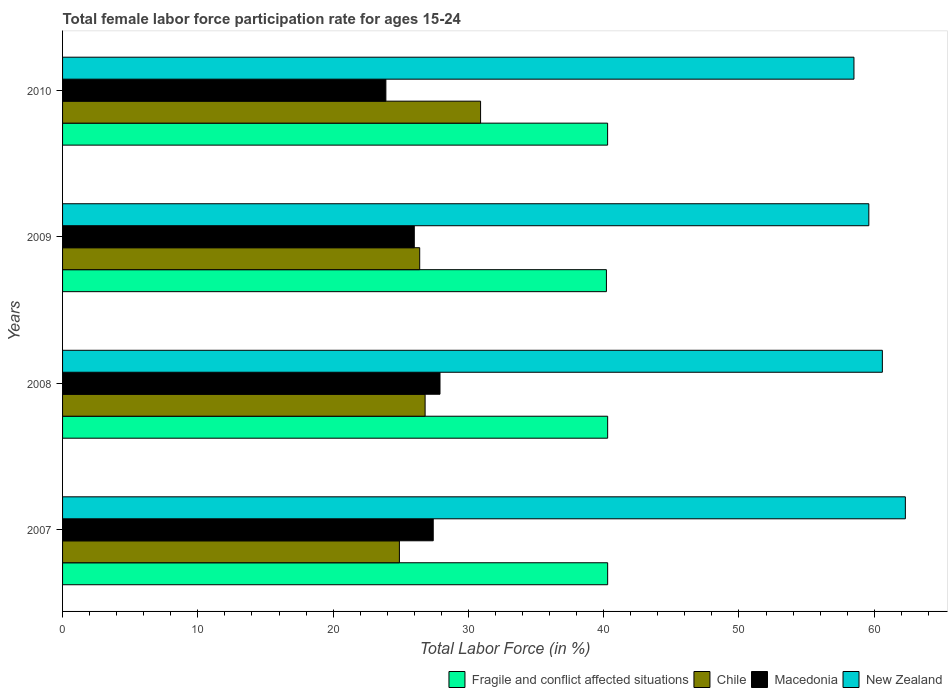Are the number of bars per tick equal to the number of legend labels?
Offer a terse response. Yes. Are the number of bars on each tick of the Y-axis equal?
Your answer should be compact. Yes. What is the female labor force participation rate in Chile in 2009?
Your answer should be very brief. 26.4. Across all years, what is the maximum female labor force participation rate in Fragile and conflict affected situations?
Give a very brief answer. 40.29. Across all years, what is the minimum female labor force participation rate in Macedonia?
Your answer should be very brief. 23.9. In which year was the female labor force participation rate in Fragile and conflict affected situations maximum?
Offer a very short reply. 2007. In which year was the female labor force participation rate in Chile minimum?
Provide a short and direct response. 2007. What is the total female labor force participation rate in Chile in the graph?
Offer a very short reply. 109. What is the difference between the female labor force participation rate in New Zealand in 2007 and that in 2008?
Ensure brevity in your answer.  1.7. What is the difference between the female labor force participation rate in Macedonia in 2009 and the female labor force participation rate in Fragile and conflict affected situations in 2008?
Keep it short and to the point. -14.29. What is the average female labor force participation rate in Chile per year?
Make the answer very short. 27.25. In the year 2009, what is the difference between the female labor force participation rate in Macedonia and female labor force participation rate in Fragile and conflict affected situations?
Offer a terse response. -14.2. In how many years, is the female labor force participation rate in New Zealand greater than 48 %?
Your answer should be compact. 4. What is the ratio of the female labor force participation rate in New Zealand in 2008 to that in 2010?
Keep it short and to the point. 1.04. Is the female labor force participation rate in New Zealand in 2008 less than that in 2009?
Give a very brief answer. No. Is the difference between the female labor force participation rate in Macedonia in 2007 and 2009 greater than the difference between the female labor force participation rate in Fragile and conflict affected situations in 2007 and 2009?
Ensure brevity in your answer.  Yes. What is the difference between the highest and the lowest female labor force participation rate in New Zealand?
Your response must be concise. 3.8. In how many years, is the female labor force participation rate in Fragile and conflict affected situations greater than the average female labor force participation rate in Fragile and conflict affected situations taken over all years?
Keep it short and to the point. 3. Is the sum of the female labor force participation rate in New Zealand in 2008 and 2009 greater than the maximum female labor force participation rate in Macedonia across all years?
Keep it short and to the point. Yes. Is it the case that in every year, the sum of the female labor force participation rate in New Zealand and female labor force participation rate in Macedonia is greater than the sum of female labor force participation rate in Chile and female labor force participation rate in Fragile and conflict affected situations?
Provide a short and direct response. Yes. What does the 4th bar from the bottom in 2009 represents?
Your response must be concise. New Zealand. How many bars are there?
Offer a terse response. 16. Are all the bars in the graph horizontal?
Ensure brevity in your answer.  Yes. Does the graph contain grids?
Ensure brevity in your answer.  No. Where does the legend appear in the graph?
Your response must be concise. Bottom right. How are the legend labels stacked?
Provide a succinct answer. Horizontal. What is the title of the graph?
Offer a very short reply. Total female labor force participation rate for ages 15-24. What is the label or title of the X-axis?
Keep it short and to the point. Total Labor Force (in %). What is the Total Labor Force (in %) in Fragile and conflict affected situations in 2007?
Your response must be concise. 40.29. What is the Total Labor Force (in %) in Chile in 2007?
Your answer should be compact. 24.9. What is the Total Labor Force (in %) in Macedonia in 2007?
Your answer should be very brief. 27.4. What is the Total Labor Force (in %) of New Zealand in 2007?
Offer a terse response. 62.3. What is the Total Labor Force (in %) of Fragile and conflict affected situations in 2008?
Offer a very short reply. 40.29. What is the Total Labor Force (in %) of Chile in 2008?
Ensure brevity in your answer.  26.8. What is the Total Labor Force (in %) in Macedonia in 2008?
Keep it short and to the point. 27.9. What is the Total Labor Force (in %) of New Zealand in 2008?
Keep it short and to the point. 60.6. What is the Total Labor Force (in %) in Fragile and conflict affected situations in 2009?
Ensure brevity in your answer.  40.2. What is the Total Labor Force (in %) of Chile in 2009?
Make the answer very short. 26.4. What is the Total Labor Force (in %) in Macedonia in 2009?
Offer a very short reply. 26. What is the Total Labor Force (in %) in New Zealand in 2009?
Provide a short and direct response. 59.6. What is the Total Labor Force (in %) in Fragile and conflict affected situations in 2010?
Make the answer very short. 40.29. What is the Total Labor Force (in %) in Chile in 2010?
Keep it short and to the point. 30.9. What is the Total Labor Force (in %) in Macedonia in 2010?
Make the answer very short. 23.9. What is the Total Labor Force (in %) of New Zealand in 2010?
Give a very brief answer. 58.5. Across all years, what is the maximum Total Labor Force (in %) in Fragile and conflict affected situations?
Ensure brevity in your answer.  40.29. Across all years, what is the maximum Total Labor Force (in %) of Chile?
Your answer should be very brief. 30.9. Across all years, what is the maximum Total Labor Force (in %) in Macedonia?
Provide a short and direct response. 27.9. Across all years, what is the maximum Total Labor Force (in %) of New Zealand?
Your answer should be compact. 62.3. Across all years, what is the minimum Total Labor Force (in %) in Fragile and conflict affected situations?
Ensure brevity in your answer.  40.2. Across all years, what is the minimum Total Labor Force (in %) of Chile?
Offer a terse response. 24.9. Across all years, what is the minimum Total Labor Force (in %) in Macedonia?
Your answer should be very brief. 23.9. Across all years, what is the minimum Total Labor Force (in %) in New Zealand?
Provide a succinct answer. 58.5. What is the total Total Labor Force (in %) of Fragile and conflict affected situations in the graph?
Ensure brevity in your answer.  161.08. What is the total Total Labor Force (in %) of Chile in the graph?
Keep it short and to the point. 109. What is the total Total Labor Force (in %) in Macedonia in the graph?
Offer a terse response. 105.2. What is the total Total Labor Force (in %) of New Zealand in the graph?
Offer a very short reply. 241. What is the difference between the Total Labor Force (in %) in Fragile and conflict affected situations in 2007 and that in 2009?
Ensure brevity in your answer.  0.09. What is the difference between the Total Labor Force (in %) in Macedonia in 2007 and that in 2009?
Offer a very short reply. 1.4. What is the difference between the Total Labor Force (in %) of New Zealand in 2007 and that in 2009?
Keep it short and to the point. 2.7. What is the difference between the Total Labor Force (in %) in Fragile and conflict affected situations in 2007 and that in 2010?
Your response must be concise. 0. What is the difference between the Total Labor Force (in %) of Chile in 2007 and that in 2010?
Your answer should be very brief. -6. What is the difference between the Total Labor Force (in %) of New Zealand in 2007 and that in 2010?
Your answer should be very brief. 3.8. What is the difference between the Total Labor Force (in %) of Fragile and conflict affected situations in 2008 and that in 2009?
Give a very brief answer. 0.09. What is the difference between the Total Labor Force (in %) of Macedonia in 2008 and that in 2009?
Keep it short and to the point. 1.9. What is the difference between the Total Labor Force (in %) in New Zealand in 2008 and that in 2009?
Your answer should be very brief. 1. What is the difference between the Total Labor Force (in %) of Fragile and conflict affected situations in 2008 and that in 2010?
Provide a succinct answer. 0. What is the difference between the Total Labor Force (in %) of New Zealand in 2008 and that in 2010?
Give a very brief answer. 2.1. What is the difference between the Total Labor Force (in %) of Fragile and conflict affected situations in 2009 and that in 2010?
Ensure brevity in your answer.  -0.09. What is the difference between the Total Labor Force (in %) in Macedonia in 2009 and that in 2010?
Keep it short and to the point. 2.1. What is the difference between the Total Labor Force (in %) of Fragile and conflict affected situations in 2007 and the Total Labor Force (in %) of Chile in 2008?
Offer a terse response. 13.49. What is the difference between the Total Labor Force (in %) in Fragile and conflict affected situations in 2007 and the Total Labor Force (in %) in Macedonia in 2008?
Your answer should be compact. 12.39. What is the difference between the Total Labor Force (in %) of Fragile and conflict affected situations in 2007 and the Total Labor Force (in %) of New Zealand in 2008?
Keep it short and to the point. -20.31. What is the difference between the Total Labor Force (in %) of Chile in 2007 and the Total Labor Force (in %) of Macedonia in 2008?
Offer a terse response. -3. What is the difference between the Total Labor Force (in %) in Chile in 2007 and the Total Labor Force (in %) in New Zealand in 2008?
Your answer should be very brief. -35.7. What is the difference between the Total Labor Force (in %) of Macedonia in 2007 and the Total Labor Force (in %) of New Zealand in 2008?
Your response must be concise. -33.2. What is the difference between the Total Labor Force (in %) of Fragile and conflict affected situations in 2007 and the Total Labor Force (in %) of Chile in 2009?
Keep it short and to the point. 13.89. What is the difference between the Total Labor Force (in %) in Fragile and conflict affected situations in 2007 and the Total Labor Force (in %) in Macedonia in 2009?
Ensure brevity in your answer.  14.29. What is the difference between the Total Labor Force (in %) of Fragile and conflict affected situations in 2007 and the Total Labor Force (in %) of New Zealand in 2009?
Give a very brief answer. -19.31. What is the difference between the Total Labor Force (in %) in Chile in 2007 and the Total Labor Force (in %) in Macedonia in 2009?
Make the answer very short. -1.1. What is the difference between the Total Labor Force (in %) of Chile in 2007 and the Total Labor Force (in %) of New Zealand in 2009?
Give a very brief answer. -34.7. What is the difference between the Total Labor Force (in %) in Macedonia in 2007 and the Total Labor Force (in %) in New Zealand in 2009?
Offer a very short reply. -32.2. What is the difference between the Total Labor Force (in %) of Fragile and conflict affected situations in 2007 and the Total Labor Force (in %) of Chile in 2010?
Keep it short and to the point. 9.39. What is the difference between the Total Labor Force (in %) in Fragile and conflict affected situations in 2007 and the Total Labor Force (in %) in Macedonia in 2010?
Your answer should be compact. 16.39. What is the difference between the Total Labor Force (in %) in Fragile and conflict affected situations in 2007 and the Total Labor Force (in %) in New Zealand in 2010?
Provide a succinct answer. -18.21. What is the difference between the Total Labor Force (in %) in Chile in 2007 and the Total Labor Force (in %) in New Zealand in 2010?
Offer a terse response. -33.6. What is the difference between the Total Labor Force (in %) of Macedonia in 2007 and the Total Labor Force (in %) of New Zealand in 2010?
Give a very brief answer. -31.1. What is the difference between the Total Labor Force (in %) in Fragile and conflict affected situations in 2008 and the Total Labor Force (in %) in Chile in 2009?
Make the answer very short. 13.89. What is the difference between the Total Labor Force (in %) in Fragile and conflict affected situations in 2008 and the Total Labor Force (in %) in Macedonia in 2009?
Keep it short and to the point. 14.29. What is the difference between the Total Labor Force (in %) in Fragile and conflict affected situations in 2008 and the Total Labor Force (in %) in New Zealand in 2009?
Ensure brevity in your answer.  -19.31. What is the difference between the Total Labor Force (in %) in Chile in 2008 and the Total Labor Force (in %) in New Zealand in 2009?
Offer a very short reply. -32.8. What is the difference between the Total Labor Force (in %) in Macedonia in 2008 and the Total Labor Force (in %) in New Zealand in 2009?
Your answer should be compact. -31.7. What is the difference between the Total Labor Force (in %) in Fragile and conflict affected situations in 2008 and the Total Labor Force (in %) in Chile in 2010?
Ensure brevity in your answer.  9.39. What is the difference between the Total Labor Force (in %) in Fragile and conflict affected situations in 2008 and the Total Labor Force (in %) in Macedonia in 2010?
Provide a short and direct response. 16.39. What is the difference between the Total Labor Force (in %) of Fragile and conflict affected situations in 2008 and the Total Labor Force (in %) of New Zealand in 2010?
Offer a terse response. -18.21. What is the difference between the Total Labor Force (in %) in Chile in 2008 and the Total Labor Force (in %) in Macedonia in 2010?
Keep it short and to the point. 2.9. What is the difference between the Total Labor Force (in %) in Chile in 2008 and the Total Labor Force (in %) in New Zealand in 2010?
Your answer should be compact. -31.7. What is the difference between the Total Labor Force (in %) in Macedonia in 2008 and the Total Labor Force (in %) in New Zealand in 2010?
Offer a very short reply. -30.6. What is the difference between the Total Labor Force (in %) of Fragile and conflict affected situations in 2009 and the Total Labor Force (in %) of Chile in 2010?
Give a very brief answer. 9.3. What is the difference between the Total Labor Force (in %) of Fragile and conflict affected situations in 2009 and the Total Labor Force (in %) of Macedonia in 2010?
Keep it short and to the point. 16.3. What is the difference between the Total Labor Force (in %) of Fragile and conflict affected situations in 2009 and the Total Labor Force (in %) of New Zealand in 2010?
Your answer should be very brief. -18.3. What is the difference between the Total Labor Force (in %) in Chile in 2009 and the Total Labor Force (in %) in New Zealand in 2010?
Your answer should be compact. -32.1. What is the difference between the Total Labor Force (in %) of Macedonia in 2009 and the Total Labor Force (in %) of New Zealand in 2010?
Your answer should be very brief. -32.5. What is the average Total Labor Force (in %) of Fragile and conflict affected situations per year?
Offer a terse response. 40.27. What is the average Total Labor Force (in %) of Chile per year?
Offer a very short reply. 27.25. What is the average Total Labor Force (in %) of Macedonia per year?
Your answer should be compact. 26.3. What is the average Total Labor Force (in %) in New Zealand per year?
Give a very brief answer. 60.25. In the year 2007, what is the difference between the Total Labor Force (in %) of Fragile and conflict affected situations and Total Labor Force (in %) of Chile?
Your answer should be compact. 15.39. In the year 2007, what is the difference between the Total Labor Force (in %) in Fragile and conflict affected situations and Total Labor Force (in %) in Macedonia?
Offer a very short reply. 12.89. In the year 2007, what is the difference between the Total Labor Force (in %) of Fragile and conflict affected situations and Total Labor Force (in %) of New Zealand?
Your answer should be very brief. -22.01. In the year 2007, what is the difference between the Total Labor Force (in %) in Chile and Total Labor Force (in %) in New Zealand?
Offer a very short reply. -37.4. In the year 2007, what is the difference between the Total Labor Force (in %) of Macedonia and Total Labor Force (in %) of New Zealand?
Offer a terse response. -34.9. In the year 2008, what is the difference between the Total Labor Force (in %) of Fragile and conflict affected situations and Total Labor Force (in %) of Chile?
Your response must be concise. 13.49. In the year 2008, what is the difference between the Total Labor Force (in %) of Fragile and conflict affected situations and Total Labor Force (in %) of Macedonia?
Your answer should be compact. 12.39. In the year 2008, what is the difference between the Total Labor Force (in %) of Fragile and conflict affected situations and Total Labor Force (in %) of New Zealand?
Your answer should be compact. -20.31. In the year 2008, what is the difference between the Total Labor Force (in %) in Chile and Total Labor Force (in %) in New Zealand?
Offer a very short reply. -33.8. In the year 2008, what is the difference between the Total Labor Force (in %) in Macedonia and Total Labor Force (in %) in New Zealand?
Make the answer very short. -32.7. In the year 2009, what is the difference between the Total Labor Force (in %) in Fragile and conflict affected situations and Total Labor Force (in %) in Chile?
Ensure brevity in your answer.  13.8. In the year 2009, what is the difference between the Total Labor Force (in %) in Fragile and conflict affected situations and Total Labor Force (in %) in Macedonia?
Ensure brevity in your answer.  14.2. In the year 2009, what is the difference between the Total Labor Force (in %) in Fragile and conflict affected situations and Total Labor Force (in %) in New Zealand?
Your response must be concise. -19.4. In the year 2009, what is the difference between the Total Labor Force (in %) in Chile and Total Labor Force (in %) in Macedonia?
Make the answer very short. 0.4. In the year 2009, what is the difference between the Total Labor Force (in %) of Chile and Total Labor Force (in %) of New Zealand?
Your answer should be compact. -33.2. In the year 2009, what is the difference between the Total Labor Force (in %) of Macedonia and Total Labor Force (in %) of New Zealand?
Your answer should be very brief. -33.6. In the year 2010, what is the difference between the Total Labor Force (in %) of Fragile and conflict affected situations and Total Labor Force (in %) of Chile?
Your response must be concise. 9.39. In the year 2010, what is the difference between the Total Labor Force (in %) of Fragile and conflict affected situations and Total Labor Force (in %) of Macedonia?
Your answer should be compact. 16.39. In the year 2010, what is the difference between the Total Labor Force (in %) in Fragile and conflict affected situations and Total Labor Force (in %) in New Zealand?
Your response must be concise. -18.21. In the year 2010, what is the difference between the Total Labor Force (in %) in Chile and Total Labor Force (in %) in New Zealand?
Your response must be concise. -27.6. In the year 2010, what is the difference between the Total Labor Force (in %) of Macedonia and Total Labor Force (in %) of New Zealand?
Make the answer very short. -34.6. What is the ratio of the Total Labor Force (in %) of Fragile and conflict affected situations in 2007 to that in 2008?
Make the answer very short. 1. What is the ratio of the Total Labor Force (in %) in Chile in 2007 to that in 2008?
Provide a short and direct response. 0.93. What is the ratio of the Total Labor Force (in %) of Macedonia in 2007 to that in 2008?
Your response must be concise. 0.98. What is the ratio of the Total Labor Force (in %) in New Zealand in 2007 to that in 2008?
Ensure brevity in your answer.  1.03. What is the ratio of the Total Labor Force (in %) of Chile in 2007 to that in 2009?
Your answer should be compact. 0.94. What is the ratio of the Total Labor Force (in %) of Macedonia in 2007 to that in 2009?
Keep it short and to the point. 1.05. What is the ratio of the Total Labor Force (in %) of New Zealand in 2007 to that in 2009?
Ensure brevity in your answer.  1.05. What is the ratio of the Total Labor Force (in %) of Chile in 2007 to that in 2010?
Your answer should be very brief. 0.81. What is the ratio of the Total Labor Force (in %) in Macedonia in 2007 to that in 2010?
Ensure brevity in your answer.  1.15. What is the ratio of the Total Labor Force (in %) in New Zealand in 2007 to that in 2010?
Make the answer very short. 1.06. What is the ratio of the Total Labor Force (in %) of Chile in 2008 to that in 2009?
Keep it short and to the point. 1.02. What is the ratio of the Total Labor Force (in %) in Macedonia in 2008 to that in 2009?
Your answer should be compact. 1.07. What is the ratio of the Total Labor Force (in %) of New Zealand in 2008 to that in 2009?
Ensure brevity in your answer.  1.02. What is the ratio of the Total Labor Force (in %) in Chile in 2008 to that in 2010?
Give a very brief answer. 0.87. What is the ratio of the Total Labor Force (in %) of Macedonia in 2008 to that in 2010?
Ensure brevity in your answer.  1.17. What is the ratio of the Total Labor Force (in %) of New Zealand in 2008 to that in 2010?
Your answer should be compact. 1.04. What is the ratio of the Total Labor Force (in %) of Chile in 2009 to that in 2010?
Provide a succinct answer. 0.85. What is the ratio of the Total Labor Force (in %) of Macedonia in 2009 to that in 2010?
Provide a succinct answer. 1.09. What is the ratio of the Total Labor Force (in %) in New Zealand in 2009 to that in 2010?
Give a very brief answer. 1.02. What is the difference between the highest and the second highest Total Labor Force (in %) in Fragile and conflict affected situations?
Ensure brevity in your answer.  0. What is the difference between the highest and the second highest Total Labor Force (in %) of Chile?
Ensure brevity in your answer.  4.1. What is the difference between the highest and the second highest Total Labor Force (in %) in New Zealand?
Keep it short and to the point. 1.7. What is the difference between the highest and the lowest Total Labor Force (in %) of Fragile and conflict affected situations?
Provide a short and direct response. 0.09. What is the difference between the highest and the lowest Total Labor Force (in %) of Chile?
Keep it short and to the point. 6. 